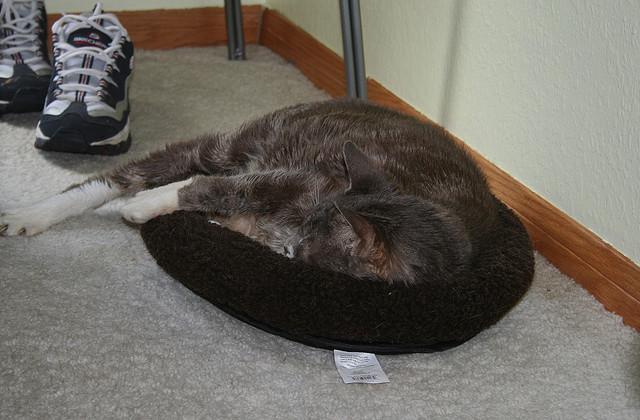Is this animal worried about where its next meal is coming from?
Concise answer only. No. What is the cat laying on?
Concise answer only. Cat bed. Is this cat running?
Answer briefly. No. 